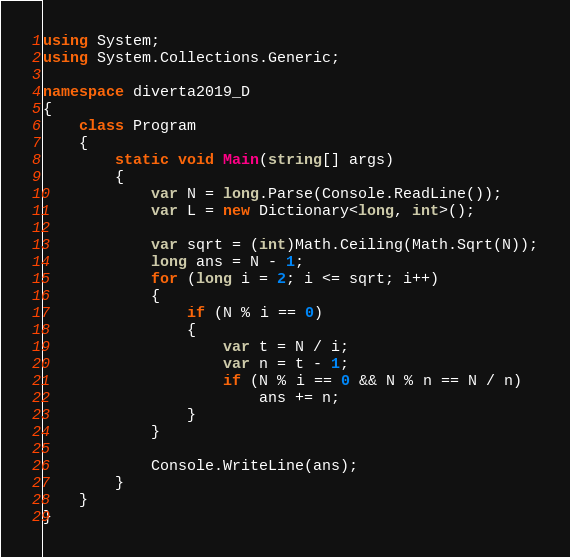Convert code to text. <code><loc_0><loc_0><loc_500><loc_500><_C#_>using System;
using System.Collections.Generic;

namespace diverta2019_D
{
    class Program
    {
        static void Main(string[] args)
        {
            var N = long.Parse(Console.ReadLine());
            var L = new Dictionary<long, int>();

            var sqrt = (int)Math.Ceiling(Math.Sqrt(N));
            long ans = N - 1;
            for (long i = 2; i <= sqrt; i++)
            {
                if (N % i == 0)
                {
                    var t = N / i;
                    var n = t - 1;
                    if (N % i == 0 && N % n == N / n)
                        ans += n;
                }
            }

            Console.WriteLine(ans);
        }
    }
}
</code> 